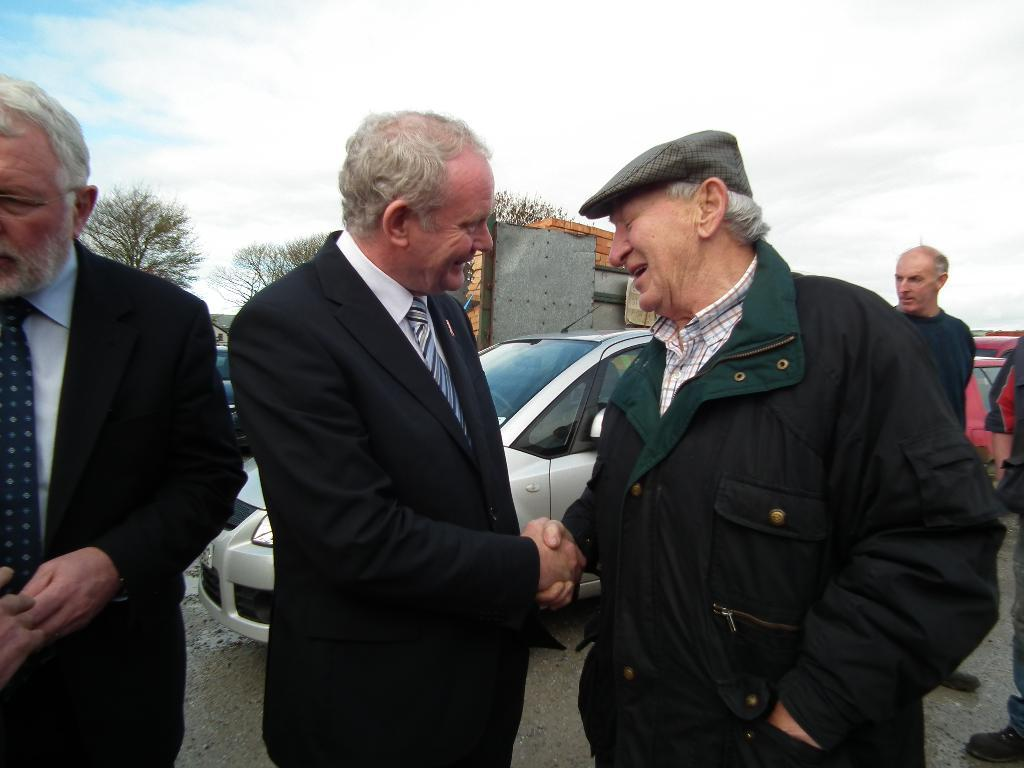What are the men in the image doing? The men in the image are standing on the road. Can you describe the expressions of the men? Some of the men are smiling. What else can be seen on the road in the background? There are motor vehicles on the road in the background. What is visible in the background of the image besides the road? There are buildings, trees, and the sky with clouds visible in the background. What type of seat is the manager using in the image? There is no mention of a seat or a manager in the image; it features men standing on the road with motor vehicles, buildings, trees, and the sky with clouds in the background. 